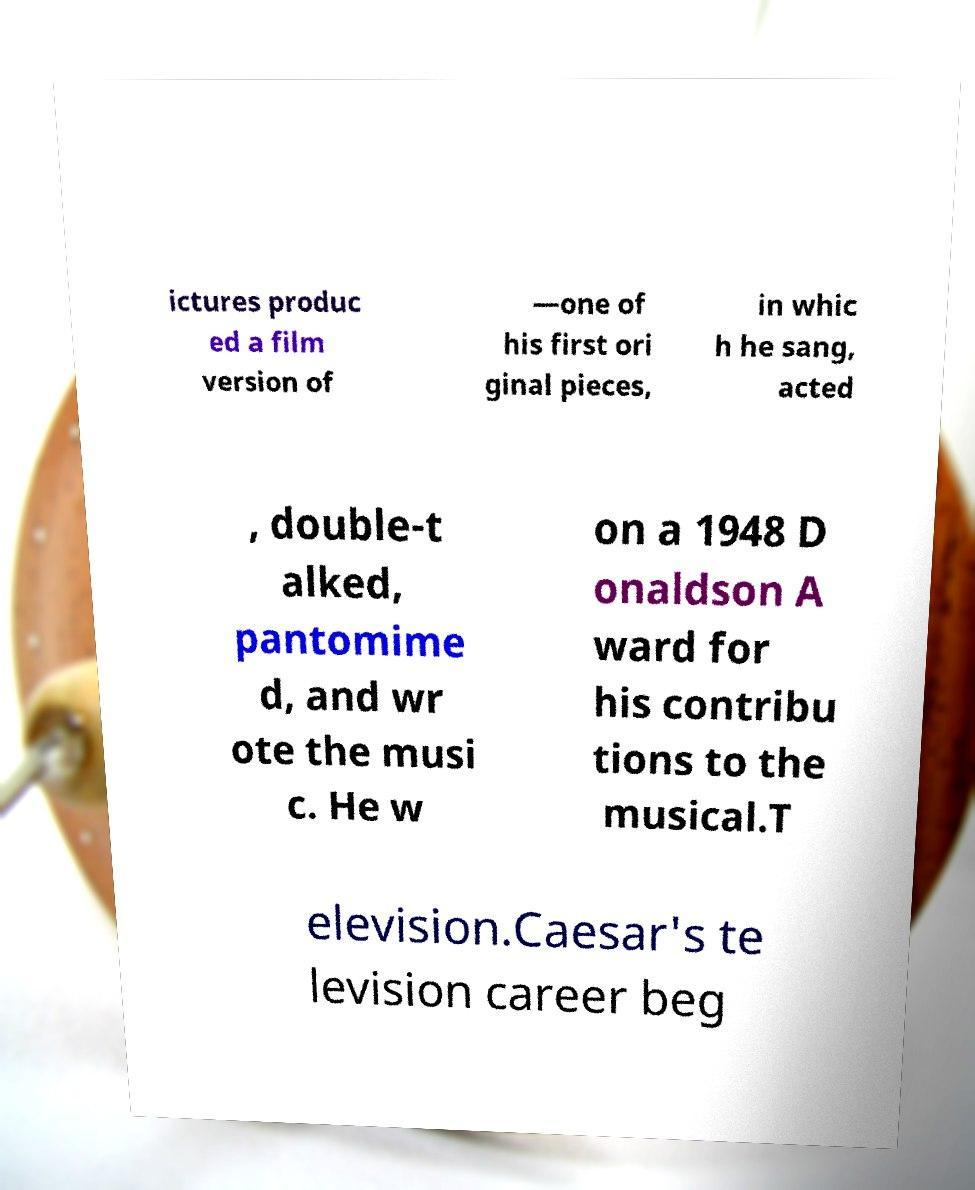Please identify and transcribe the text found in this image. ictures produc ed a film version of —one of his first ori ginal pieces, in whic h he sang, acted , double-t alked, pantomime d, and wr ote the musi c. He w on a 1948 D onaldson A ward for his contribu tions to the musical.T elevision.Caesar's te levision career beg 